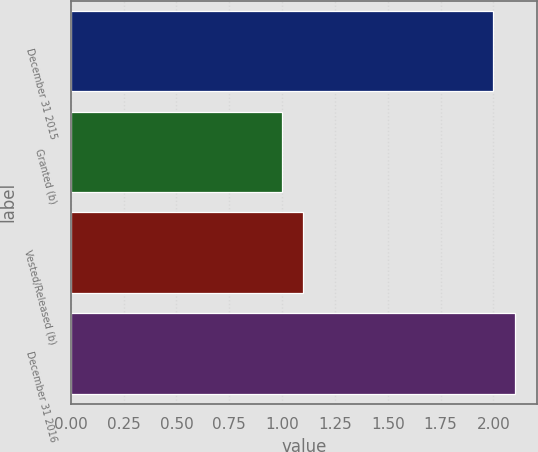Convert chart to OTSL. <chart><loc_0><loc_0><loc_500><loc_500><bar_chart><fcel>December 31 2015<fcel>Granted (b)<fcel>Vested/Released (b)<fcel>December 31 2016<nl><fcel>2<fcel>1<fcel>1.1<fcel>2.1<nl></chart> 